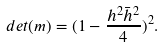<formula> <loc_0><loc_0><loc_500><loc_500>d e t ( m ) = ( 1 - \frac { h ^ { 2 } \bar { h } ^ { 2 } } { 4 } ) ^ { 2 } .</formula> 